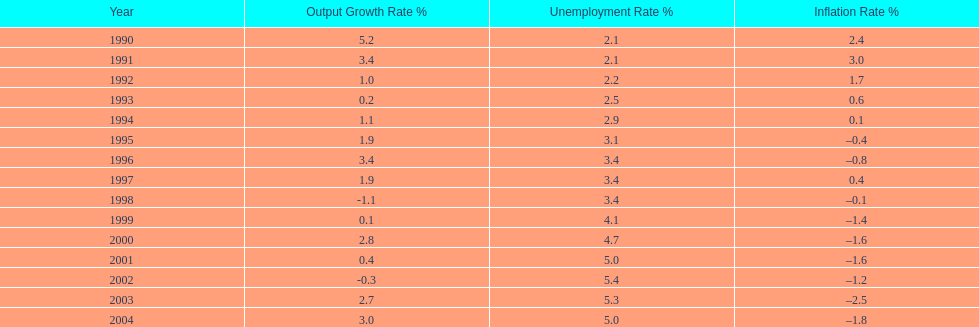Were the highest unemployment rates in japan before or after the year 2000? After. 